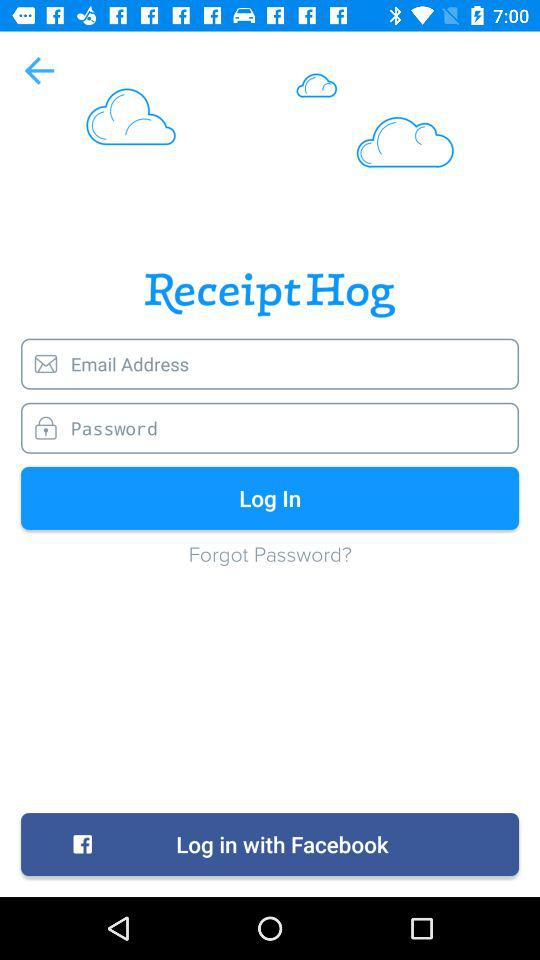What is the name of the application asking you to provide your email and password? The name of the application is "Receipt Hog". 